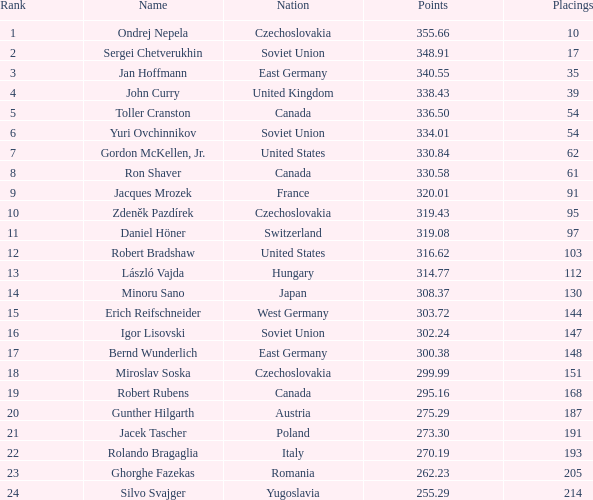What is the count of placings with points under 330.84 and having a name of silvo svajger? 1.0. 